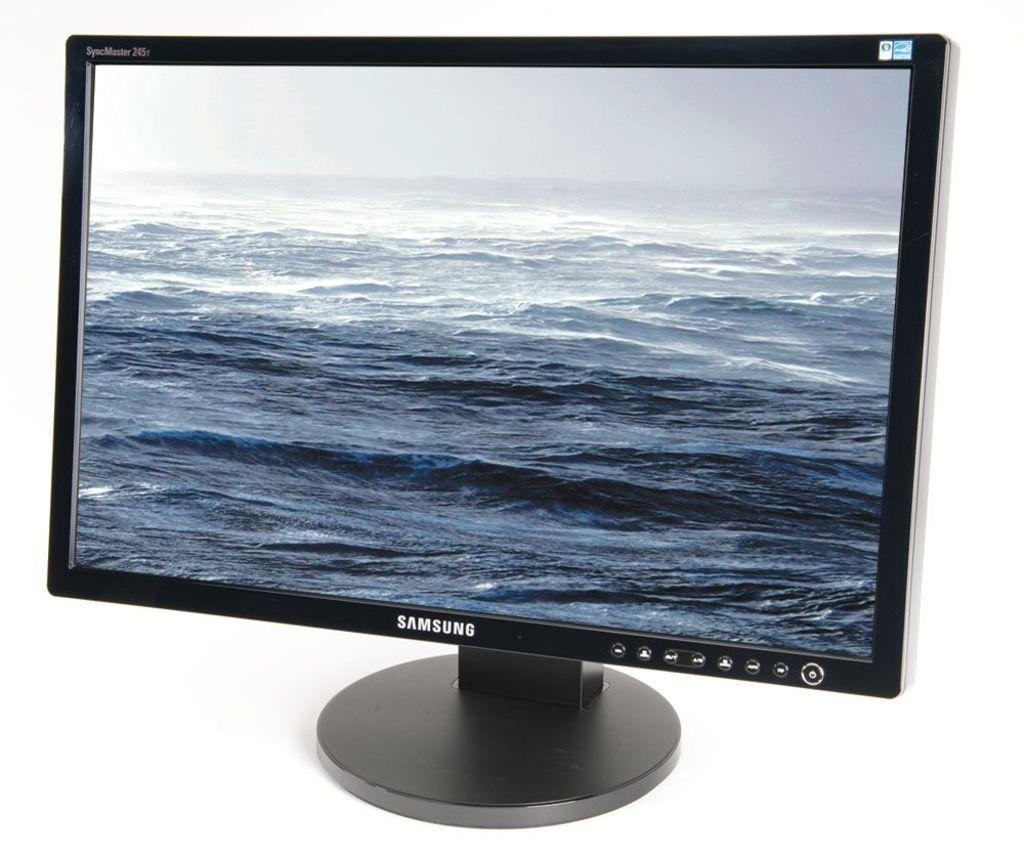<image>
Share a concise interpretation of the image provided. A Samsung computer monitor against a white backdrop. 